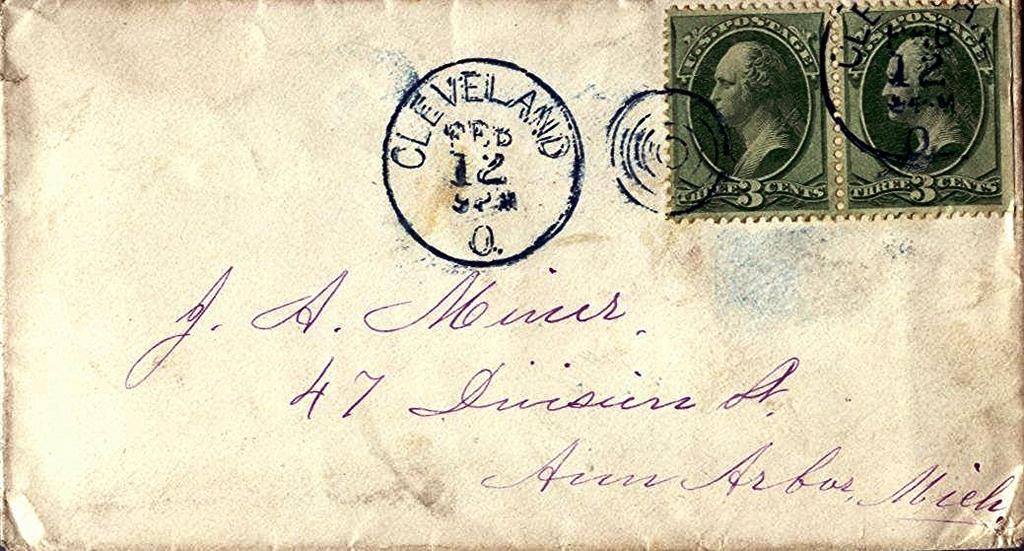<image>
Give a short and clear explanation of the subsequent image. An envelope with two stamps in the top right corner and a postmark from Cleveland. 